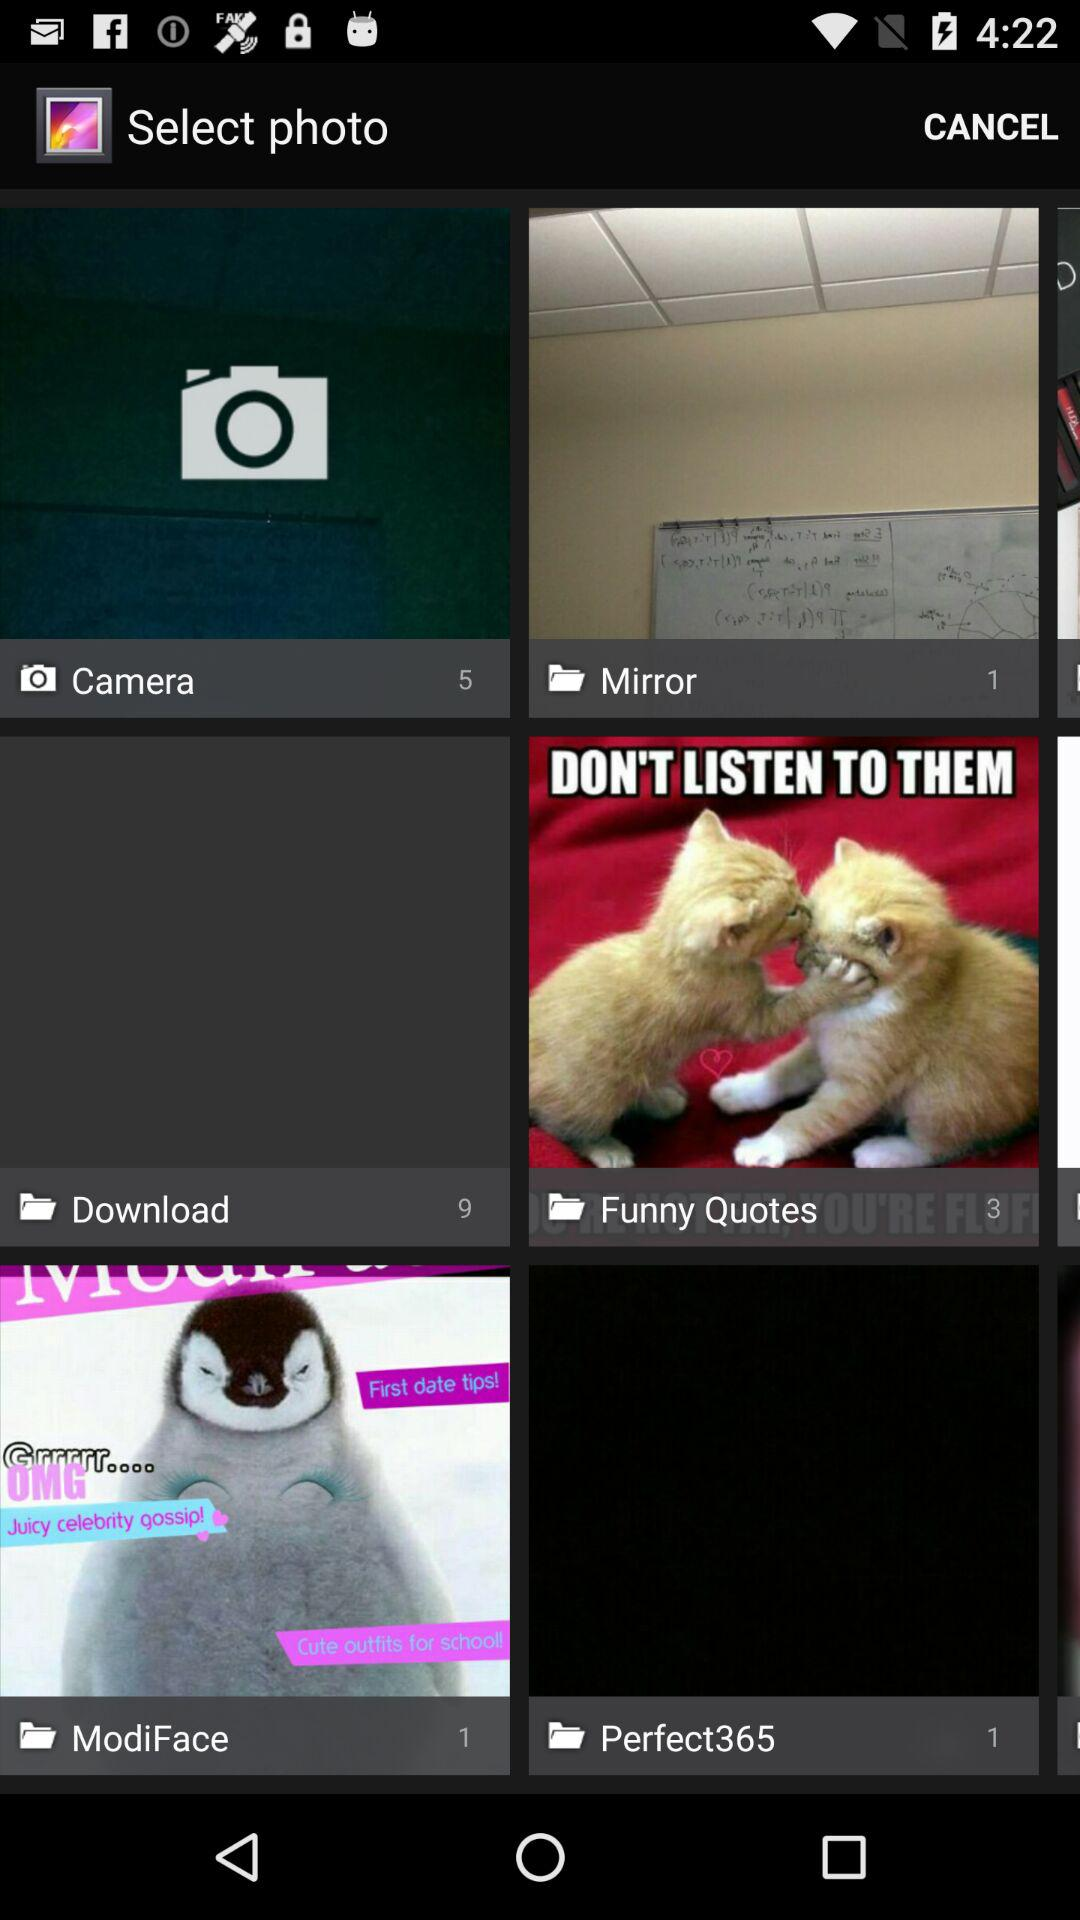How many pictures are in the "Download" folder? There are 9 pictures in the "Download" folder. 